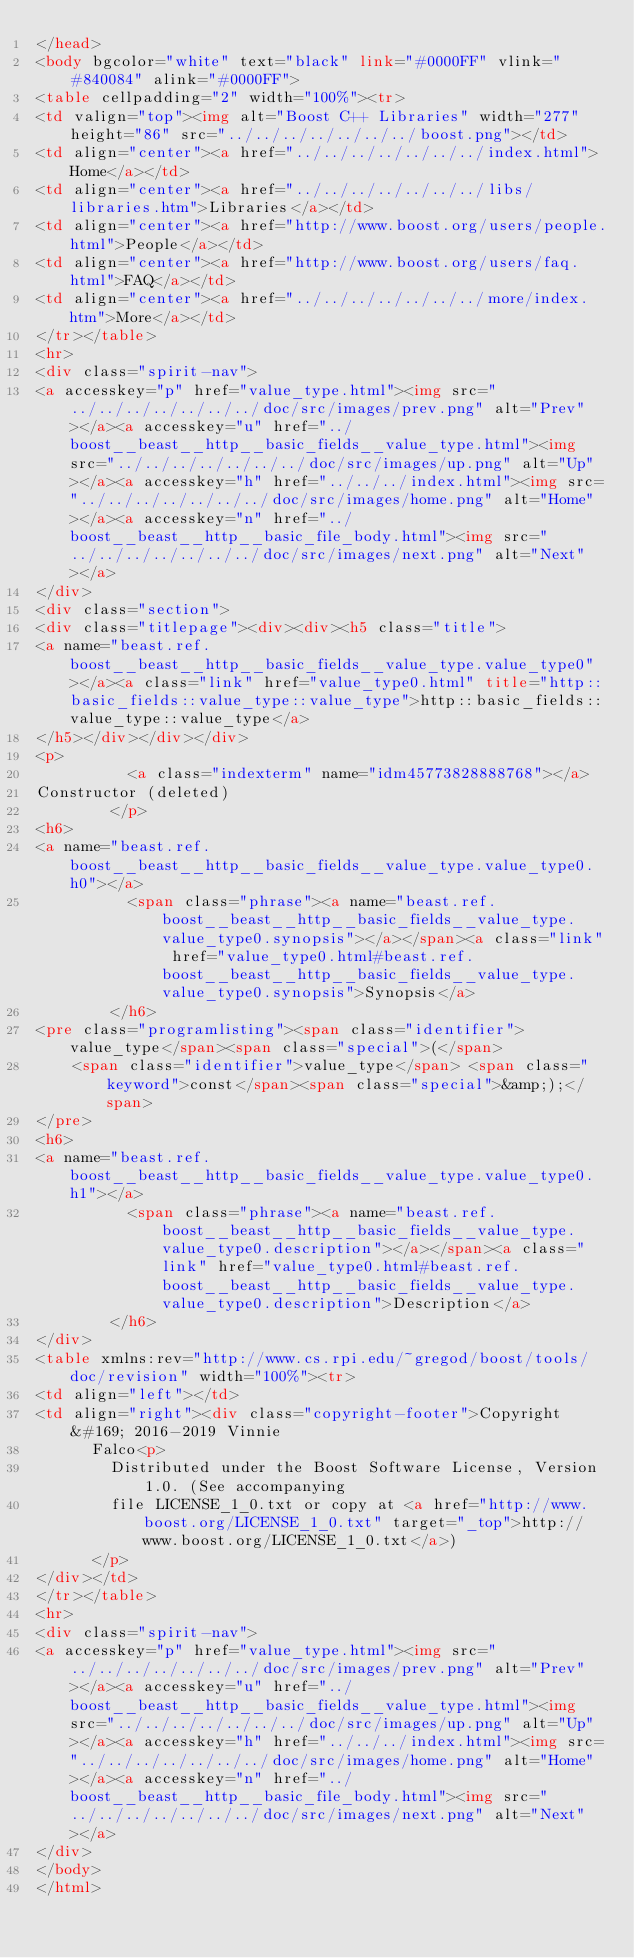Convert code to text. <code><loc_0><loc_0><loc_500><loc_500><_HTML_></head>
<body bgcolor="white" text="black" link="#0000FF" vlink="#840084" alink="#0000FF">
<table cellpadding="2" width="100%"><tr>
<td valign="top"><img alt="Boost C++ Libraries" width="277" height="86" src="../../../../../../../boost.png"></td>
<td align="center"><a href="../../../../../../../index.html">Home</a></td>
<td align="center"><a href="../../../../../../../libs/libraries.htm">Libraries</a></td>
<td align="center"><a href="http://www.boost.org/users/people.html">People</a></td>
<td align="center"><a href="http://www.boost.org/users/faq.html">FAQ</a></td>
<td align="center"><a href="../../../../../../../more/index.htm">More</a></td>
</tr></table>
<hr>
<div class="spirit-nav">
<a accesskey="p" href="value_type.html"><img src="../../../../../../../doc/src/images/prev.png" alt="Prev"></a><a accesskey="u" href="../boost__beast__http__basic_fields__value_type.html"><img src="../../../../../../../doc/src/images/up.png" alt="Up"></a><a accesskey="h" href="../../../index.html"><img src="../../../../../../../doc/src/images/home.png" alt="Home"></a><a accesskey="n" href="../boost__beast__http__basic_file_body.html"><img src="../../../../../../../doc/src/images/next.png" alt="Next"></a>
</div>
<div class="section">
<div class="titlepage"><div><div><h5 class="title">
<a name="beast.ref.boost__beast__http__basic_fields__value_type.value_type0"></a><a class="link" href="value_type0.html" title="http::basic_fields::value_type::value_type">http::basic_fields::value_type::value_type</a>
</h5></div></div></div>
<p>
          <a class="indexterm" name="idm45773828888768"></a>
Constructor (deleted)
        </p>
<h6>
<a name="beast.ref.boost__beast__http__basic_fields__value_type.value_type0.h0"></a>
          <span class="phrase"><a name="beast.ref.boost__beast__http__basic_fields__value_type.value_type0.synopsis"></a></span><a class="link" href="value_type0.html#beast.ref.boost__beast__http__basic_fields__value_type.value_type0.synopsis">Synopsis</a>
        </h6>
<pre class="programlisting"><span class="identifier">value_type</span><span class="special">(</span>
    <span class="identifier">value_type</span> <span class="keyword">const</span><span class="special">&amp;);</span>
</pre>
<h6>
<a name="beast.ref.boost__beast__http__basic_fields__value_type.value_type0.h1"></a>
          <span class="phrase"><a name="beast.ref.boost__beast__http__basic_fields__value_type.value_type0.description"></a></span><a class="link" href="value_type0.html#beast.ref.boost__beast__http__basic_fields__value_type.value_type0.description">Description</a>
        </h6>
</div>
<table xmlns:rev="http://www.cs.rpi.edu/~gregod/boost/tools/doc/revision" width="100%"><tr>
<td align="left"></td>
<td align="right"><div class="copyright-footer">Copyright &#169; 2016-2019 Vinnie
      Falco<p>
        Distributed under the Boost Software License, Version 1.0. (See accompanying
        file LICENSE_1_0.txt or copy at <a href="http://www.boost.org/LICENSE_1_0.txt" target="_top">http://www.boost.org/LICENSE_1_0.txt</a>)
      </p>
</div></td>
</tr></table>
<hr>
<div class="spirit-nav">
<a accesskey="p" href="value_type.html"><img src="../../../../../../../doc/src/images/prev.png" alt="Prev"></a><a accesskey="u" href="../boost__beast__http__basic_fields__value_type.html"><img src="../../../../../../../doc/src/images/up.png" alt="Up"></a><a accesskey="h" href="../../../index.html"><img src="../../../../../../../doc/src/images/home.png" alt="Home"></a><a accesskey="n" href="../boost__beast__http__basic_file_body.html"><img src="../../../../../../../doc/src/images/next.png" alt="Next"></a>
</div>
</body>
</html>
</code> 